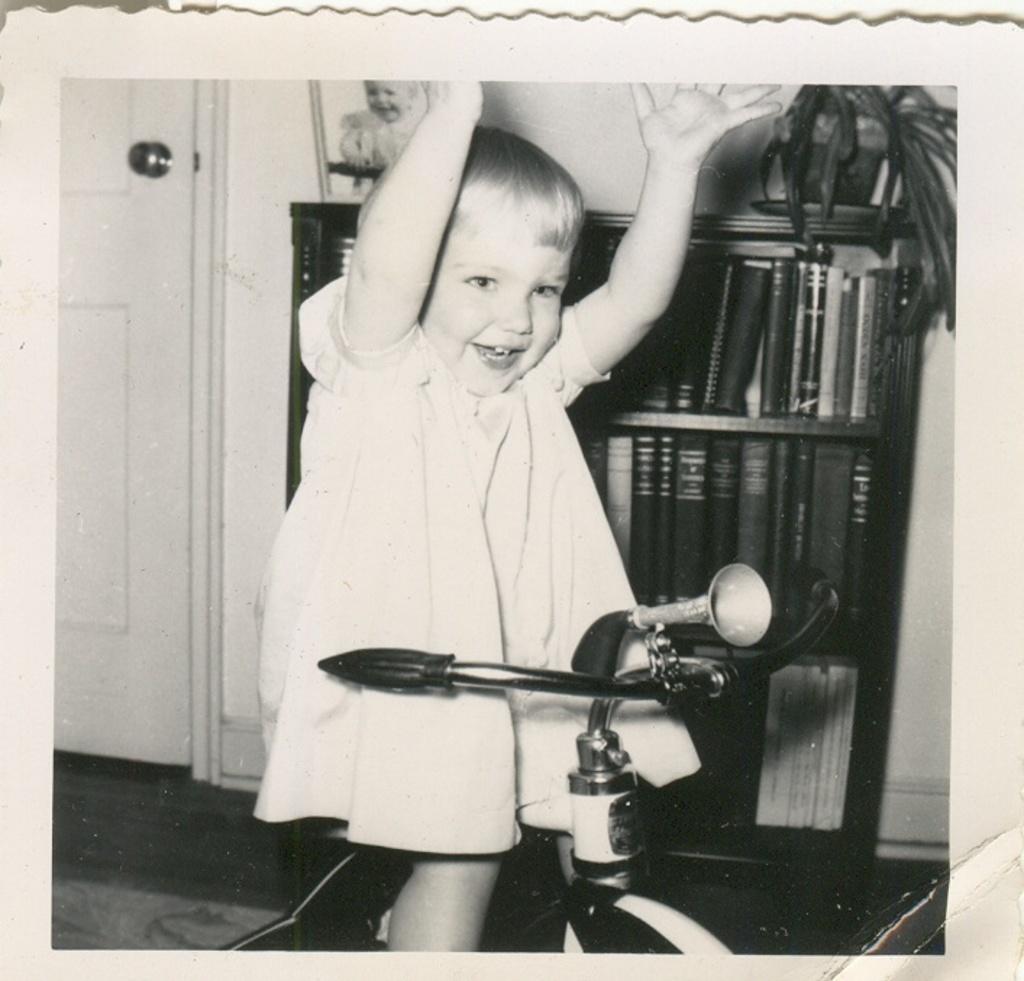Please provide a concise description of this image. This is a black and white image. In the middle of this image, there is a baby smiling and standing. Between this baby legs, there is a bike. In the background, there are books arranged on the shelves of a cupboard, on top of this cupboard, there is a photo frame and a potted plant, there is a door and there is a wall. 